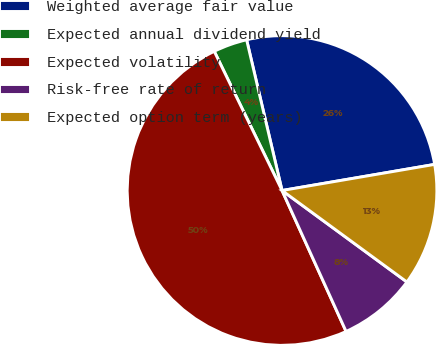<chart> <loc_0><loc_0><loc_500><loc_500><pie_chart><fcel>Weighted average fair value<fcel>Expected annual dividend yield<fcel>Expected volatility<fcel>Risk-free rate of return<fcel>Expected option term (years)<nl><fcel>25.98%<fcel>3.54%<fcel>49.58%<fcel>8.15%<fcel>12.76%<nl></chart> 